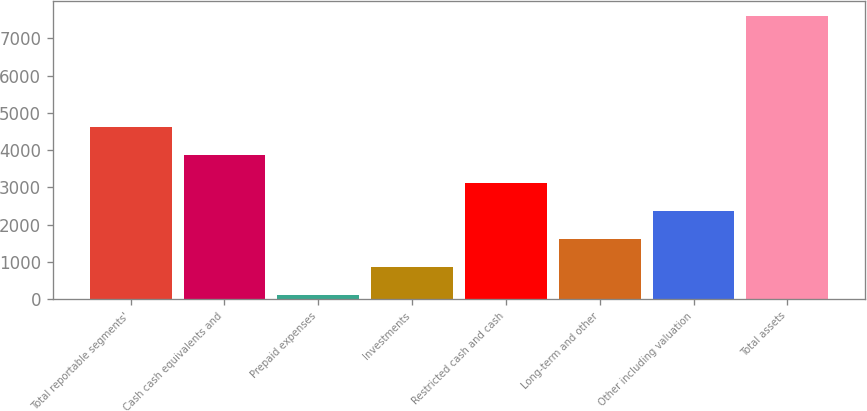<chart> <loc_0><loc_0><loc_500><loc_500><bar_chart><fcel>Total reportable segments'<fcel>Cash cash equivalents and<fcel>Prepaid expenses<fcel>Investments<fcel>Restricted cash and cash<fcel>Long-term and other<fcel>Other including valuation<fcel>Total assets<nl><fcel>4614.8<fcel>3865.5<fcel>119<fcel>868.3<fcel>3116.2<fcel>1617.6<fcel>2366.9<fcel>7612<nl></chart> 